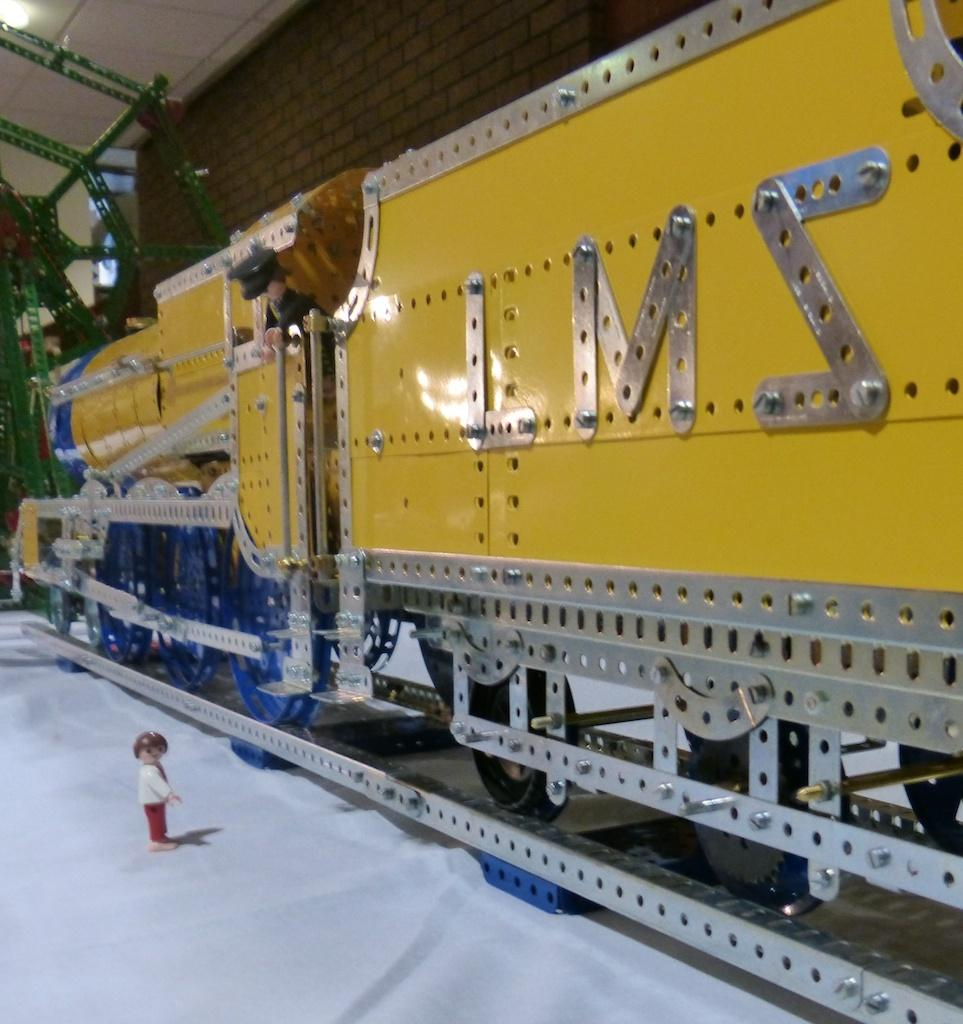<image>
Give a short and clear explanation of the subsequent image. A model train with the letters LMS on the side. 